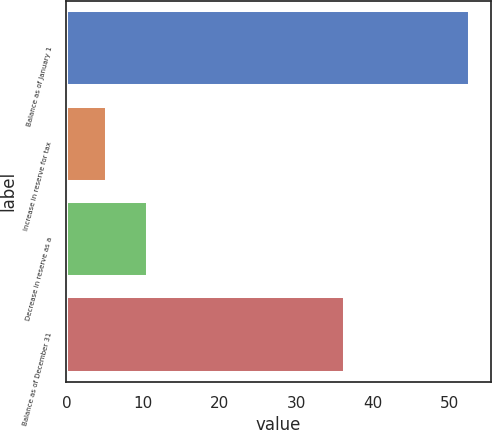Convert chart to OTSL. <chart><loc_0><loc_0><loc_500><loc_500><bar_chart><fcel>Balance as of January 1<fcel>Increase in reserve for tax<fcel>Decrease in reserve as a<fcel>Balance as of December 31<nl><fcel>52.7<fcel>5.36<fcel>10.62<fcel>36.4<nl></chart> 